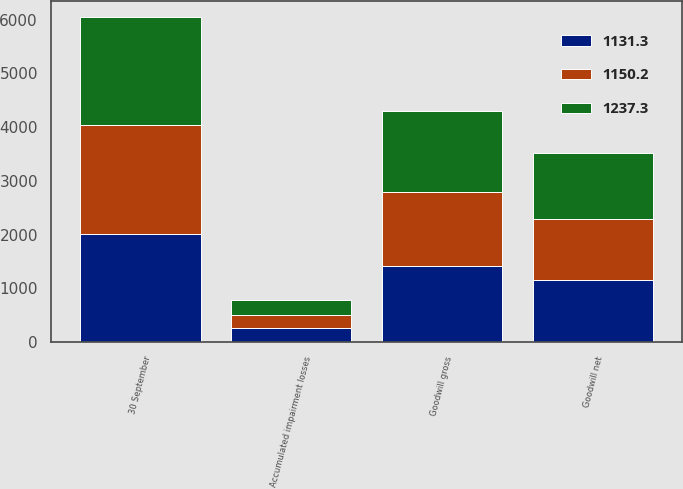<chart> <loc_0><loc_0><loc_500><loc_500><stacked_bar_chart><ecel><fcel>30 September<fcel>Goodwill gross<fcel>Accumulated impairment losses<fcel>Goodwill net<nl><fcel>1131.3<fcel>2016<fcel>1408.8<fcel>258.6<fcel>1150.2<nl><fcel>1150.2<fcel>2015<fcel>1375<fcel>243.7<fcel>1131.3<nl><fcel>1237.3<fcel>2014<fcel>1522.1<fcel>284.8<fcel>1237.3<nl></chart> 